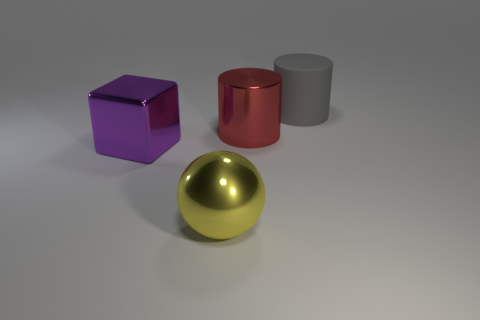Subtract 1 cylinders. How many cylinders are left? 1 Subtract all green cubes. Subtract all yellow spheres. How many cubes are left? 1 Subtract all purple cylinders. How many yellow blocks are left? 0 Subtract all small purple metallic cylinders. Subtract all large rubber things. How many objects are left? 3 Add 3 purple metal things. How many purple metal things are left? 4 Add 2 big yellow metal cylinders. How many big yellow metal cylinders exist? 2 Add 1 gray things. How many objects exist? 5 Subtract 0 red cubes. How many objects are left? 4 Subtract all blocks. How many objects are left? 3 